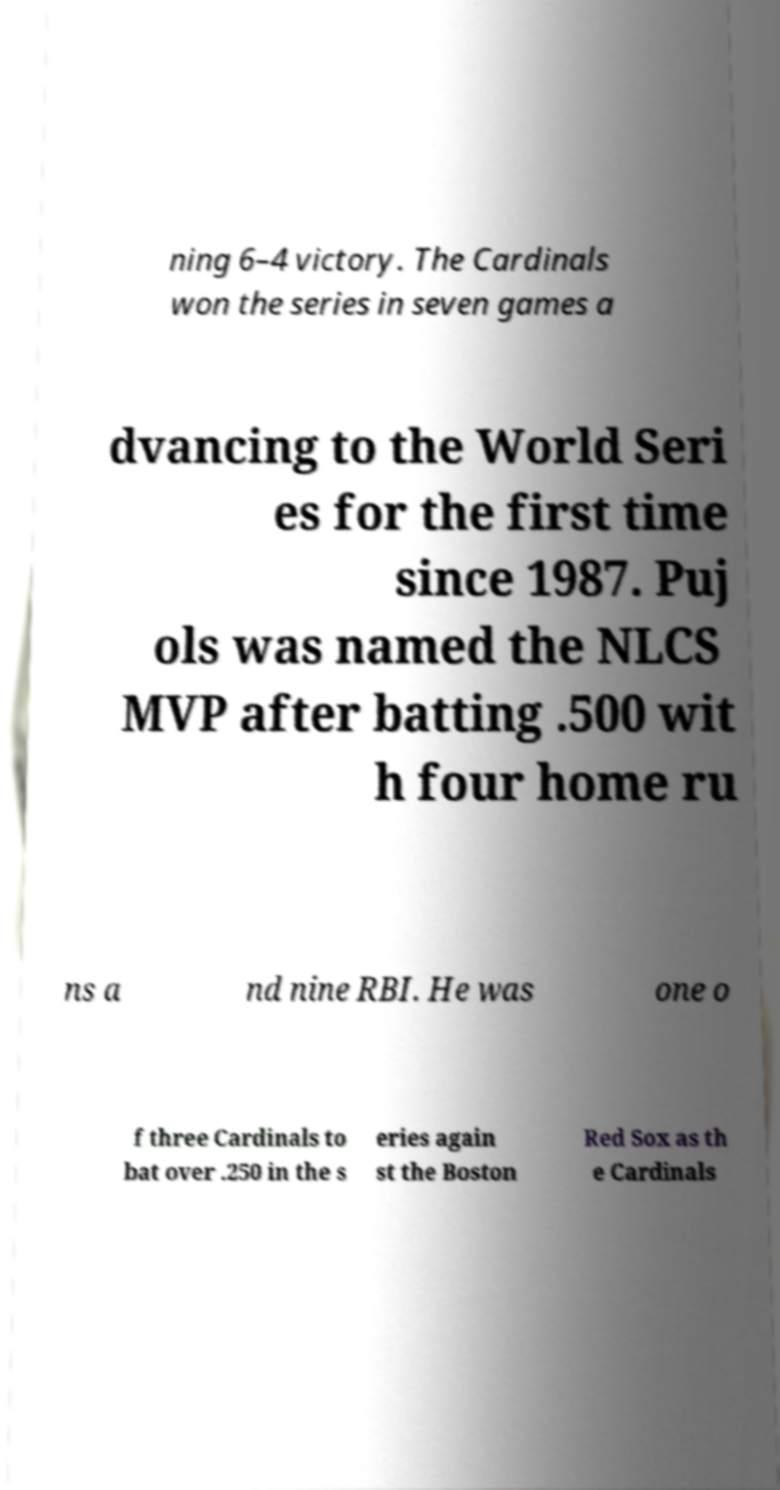Please identify and transcribe the text found in this image. ning 6–4 victory. The Cardinals won the series in seven games a dvancing to the World Seri es for the first time since 1987. Puj ols was named the NLCS MVP after batting .500 wit h four home ru ns a nd nine RBI. He was one o f three Cardinals to bat over .250 in the s eries again st the Boston Red Sox as th e Cardinals 